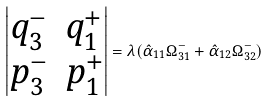Convert formula to latex. <formula><loc_0><loc_0><loc_500><loc_500>\begin{vmatrix} q _ { 3 } ^ { - } & q _ { 1 } ^ { + } \\ p _ { 3 } ^ { - } & p _ { 1 } ^ { + } \end{vmatrix} = \lambda ( \hat { \alpha } _ { 1 1 } \Omega _ { 3 1 } ^ { - } + \hat { \alpha } _ { 1 2 } \Omega _ { 3 2 } ^ { - } )</formula> 